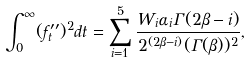<formula> <loc_0><loc_0><loc_500><loc_500>\int _ { 0 } ^ { \infty } ( f _ { t } ^ { \prime \prime } ) ^ { 2 } d t = \sum _ { i = 1 } ^ { 5 } \frac { W _ { i } \alpha _ { i } \Gamma ( 2 \beta - i ) } { 2 ^ { ( 2 \beta - i ) } ( \Gamma ( \beta ) ) ^ { 2 } } ,</formula> 